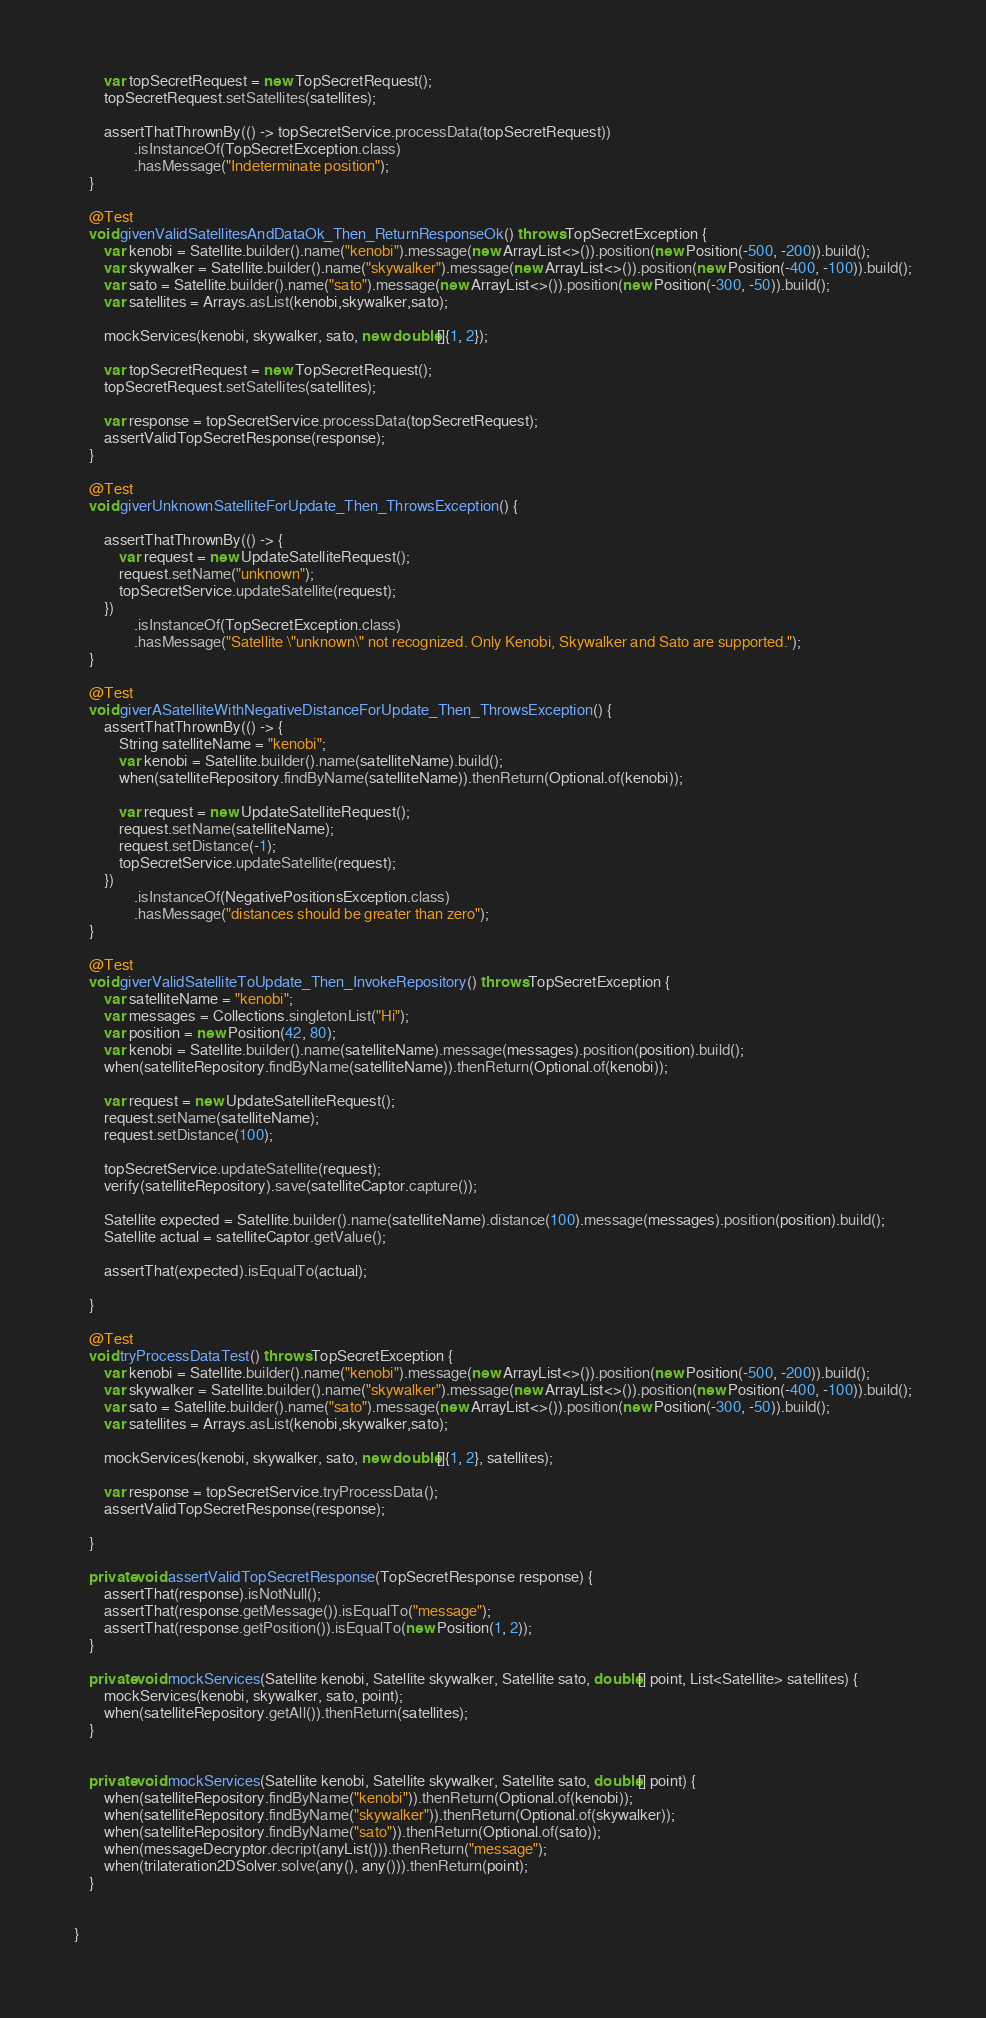Convert code to text. <code><loc_0><loc_0><loc_500><loc_500><_Java_>
        var topSecretRequest = new TopSecretRequest();
        topSecretRequest.setSatellites(satellites);

        assertThatThrownBy(() -> topSecretService.processData(topSecretRequest))
                .isInstanceOf(TopSecretException.class)
                .hasMessage("Indeterminate position");
    }

    @Test
    void givenValidSatellitesAndDataOk_Then_ReturnResponseOk() throws TopSecretException {
        var kenobi = Satellite.builder().name("kenobi").message(new ArrayList<>()).position(new Position(-500, -200)).build();
        var skywalker = Satellite.builder().name("skywalker").message(new ArrayList<>()).position(new Position(-400, -100)).build();
        var sato = Satellite.builder().name("sato").message(new ArrayList<>()).position(new Position(-300, -50)).build();
        var satellites = Arrays.asList(kenobi,skywalker,sato);

        mockServices(kenobi, skywalker, sato, new double[]{1, 2});

        var topSecretRequest = new TopSecretRequest();
        topSecretRequest.setSatellites(satellites);

        var response = topSecretService.processData(topSecretRequest);
        assertValidTopSecretResponse(response);
    }

    @Test
    void giverUnknownSatelliteForUpdate_Then_ThrowsException() {

        assertThatThrownBy(() -> {
            var request = new UpdateSatelliteRequest();
            request.setName("unknown");
            topSecretService.updateSatellite(request);
        })
                .isInstanceOf(TopSecretException.class)
                .hasMessage("Satellite \"unknown\" not recognized. Only Kenobi, Skywalker and Sato are supported.");
    }

    @Test
    void giverASatelliteWithNegativeDistanceForUpdate_Then_ThrowsException() {
        assertThatThrownBy(() -> {
            String satelliteName = "kenobi";
            var kenobi = Satellite.builder().name(satelliteName).build();
            when(satelliteRepository.findByName(satelliteName)).thenReturn(Optional.of(kenobi));

            var request = new UpdateSatelliteRequest();
            request.setName(satelliteName);
            request.setDistance(-1);
            topSecretService.updateSatellite(request);
        })
                .isInstanceOf(NegativePositionsException.class)
                .hasMessage("distances should be greater than zero");
    }

    @Test
    void giverValidSatelliteToUpdate_Then_InvokeRepository() throws TopSecretException {
        var satelliteName = "kenobi";
        var messages = Collections.singletonList("Hi");
        var position = new Position(42, 80);
        var kenobi = Satellite.builder().name(satelliteName).message(messages).position(position).build();
        when(satelliteRepository.findByName(satelliteName)).thenReturn(Optional.of(kenobi));

        var request = new UpdateSatelliteRequest();
        request.setName(satelliteName);
        request.setDistance(100);

        topSecretService.updateSatellite(request);
        verify(satelliteRepository).save(satelliteCaptor.capture());

        Satellite expected = Satellite.builder().name(satelliteName).distance(100).message(messages).position(position).build();
        Satellite actual = satelliteCaptor.getValue();

        assertThat(expected).isEqualTo(actual);

    }

    @Test
    void tryProcessDataTest() throws TopSecretException {
        var kenobi = Satellite.builder().name("kenobi").message(new ArrayList<>()).position(new Position(-500, -200)).build();
        var skywalker = Satellite.builder().name("skywalker").message(new ArrayList<>()).position(new Position(-400, -100)).build();
        var sato = Satellite.builder().name("sato").message(new ArrayList<>()).position(new Position(-300, -50)).build();
        var satellites = Arrays.asList(kenobi,skywalker,sato);

        mockServices(kenobi, skywalker, sato, new double[]{1, 2}, satellites);

        var response = topSecretService.tryProcessData();
        assertValidTopSecretResponse(response);

    }

    private void assertValidTopSecretResponse(TopSecretResponse response) {
        assertThat(response).isNotNull();
        assertThat(response.getMessage()).isEqualTo("message");
        assertThat(response.getPosition()).isEqualTo(new Position(1, 2));
    }

    private void mockServices(Satellite kenobi, Satellite skywalker, Satellite sato, double[] point, List<Satellite> satellites) {
        mockServices(kenobi, skywalker, sato, point);
        when(satelliteRepository.getAll()).thenReturn(satellites);
    }


    private void mockServices(Satellite kenobi, Satellite skywalker, Satellite sato, double[] point) {
        when(satelliteRepository.findByName("kenobi")).thenReturn(Optional.of(kenobi));
        when(satelliteRepository.findByName("skywalker")).thenReturn(Optional.of(skywalker));
        when(satelliteRepository.findByName("sato")).thenReturn(Optional.of(sato));
        when(messageDecryptor.decript(anyList())).thenReturn("message");
        when(trilateration2DSolver.solve(any(), any())).thenReturn(point);
    }


}</code> 